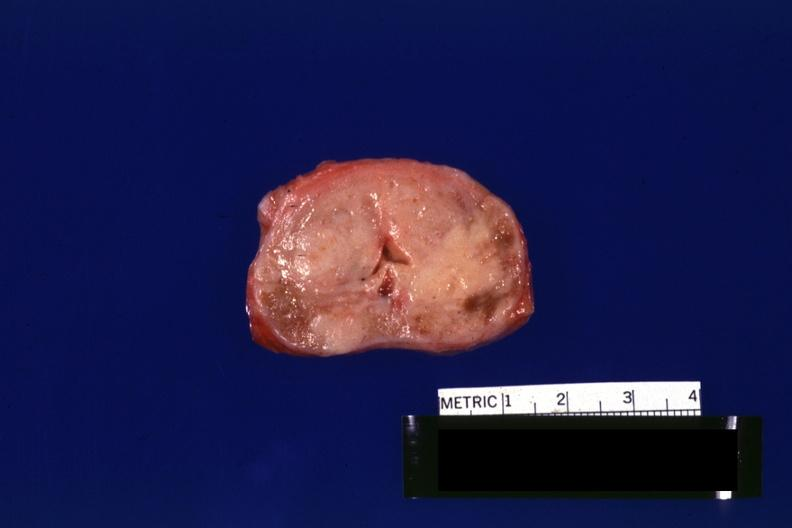does this image show excellent example to see neoplasm gland is not enlarged?
Answer the question using a single word or phrase. Yes 